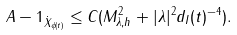<formula> <loc_0><loc_0><loc_500><loc_500>\| A - 1 \| _ { \dot { X } _ { \phi ( t ) } } \leq C ( M _ { \lambda , h } ^ { 2 } + | \lambda | ^ { 2 } d _ { I } ( t ) ^ { - 4 } ) .</formula> 